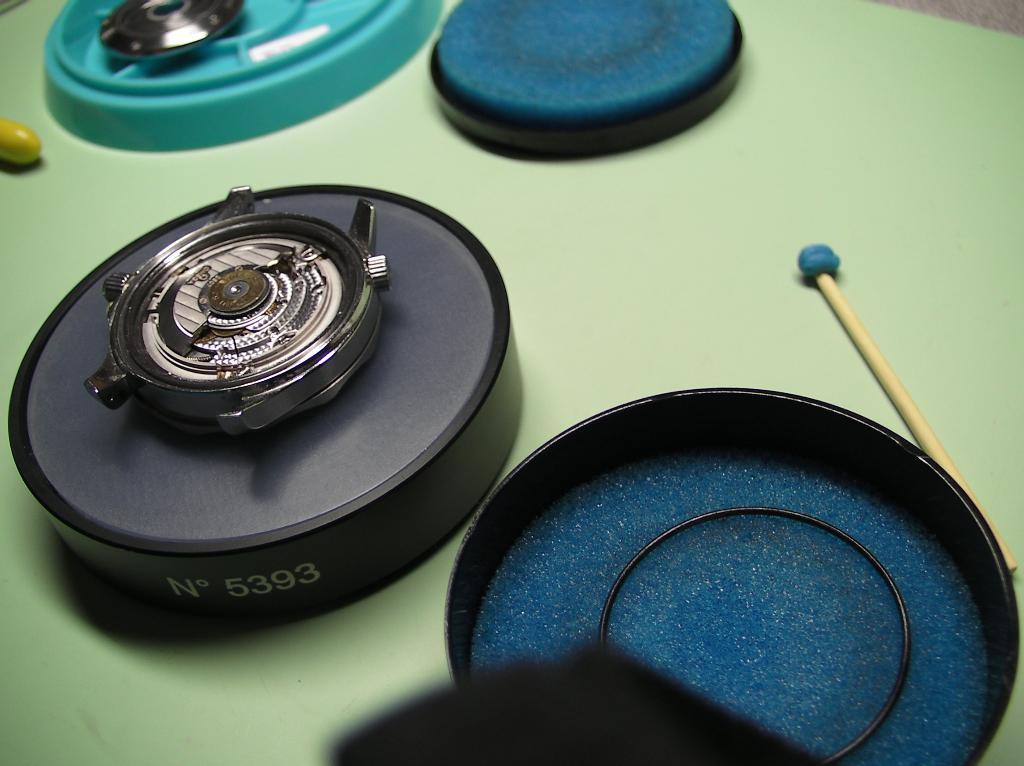What is the number on the disk?
Ensure brevity in your answer.  5393. 